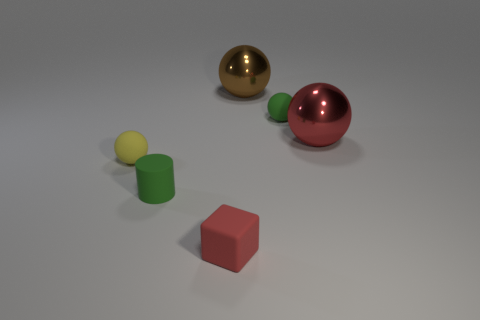The green thing that is left of the large brown metal thing that is to the right of the green cylinder is made of what material?
Offer a terse response. Rubber. What color is the object that is the same material as the brown ball?
Offer a terse response. Red. Is the size of the red object behind the tiny red matte thing the same as the red thing in front of the yellow rubber ball?
Offer a very short reply. No. What number of cylinders are brown shiny things or tiny green objects?
Ensure brevity in your answer.  1. Is the big sphere on the left side of the large red shiny ball made of the same material as the red sphere?
Offer a very short reply. Yes. What number of other objects are the same size as the red matte object?
Your answer should be compact. 3. What number of tiny objects are either brown metallic things or blue matte blocks?
Give a very brief answer. 0. Are there more big shiny spheres that are behind the block than brown objects that are in front of the green matte cylinder?
Ensure brevity in your answer.  Yes. There is a big thing that is right of the green rubber ball; is its color the same as the rubber block?
Keep it short and to the point. Yes. Is there anything else of the same color as the tiny cube?
Your response must be concise. Yes. 